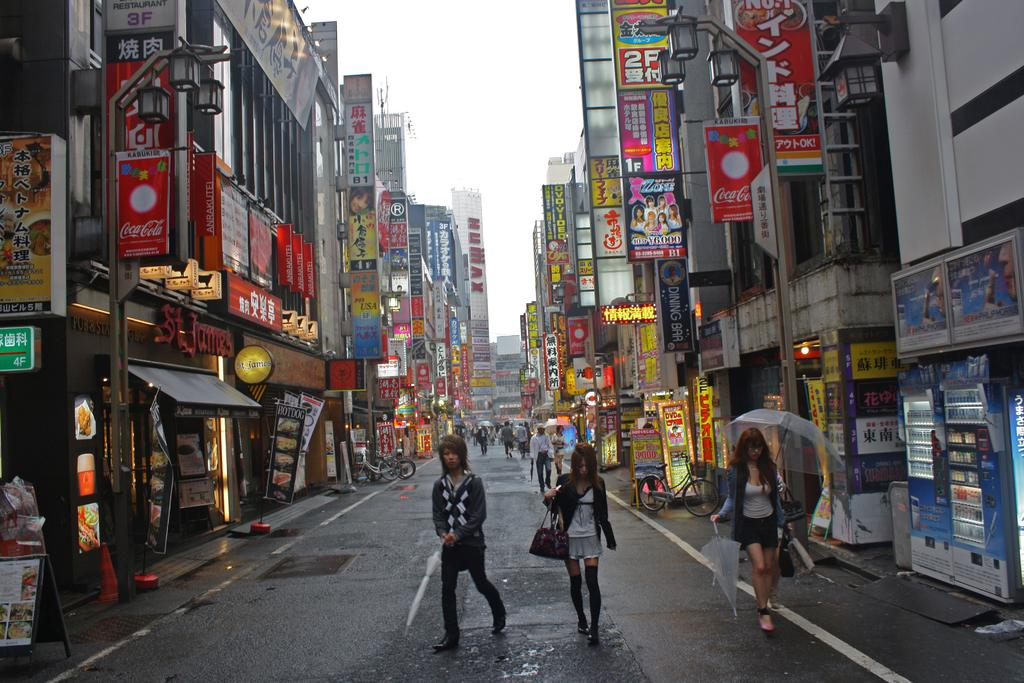How many people are in the image? There is a group of people in the image. What are the people doing in the image? The people are walking on the street. What are the people holding while walking on the street? The people are holding umbrellas. What can be seen in the background of the image? There are buildings, name boards, hoardings, refrigerators, lights, and the sky visible in the background of the image. What type of thread is being used to sew the moon into the image? There is no moon present in the image, and therefore no thread or sewing is involved. 